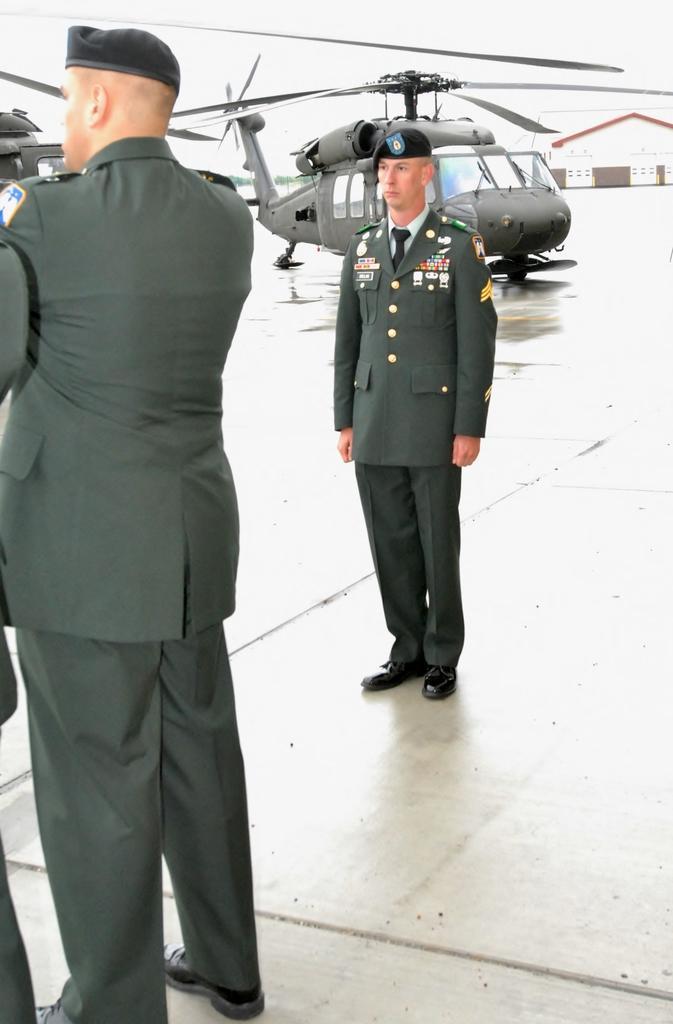In one or two sentences, can you explain what this image depicts? In this image there are people, helicopters, building and sky.   